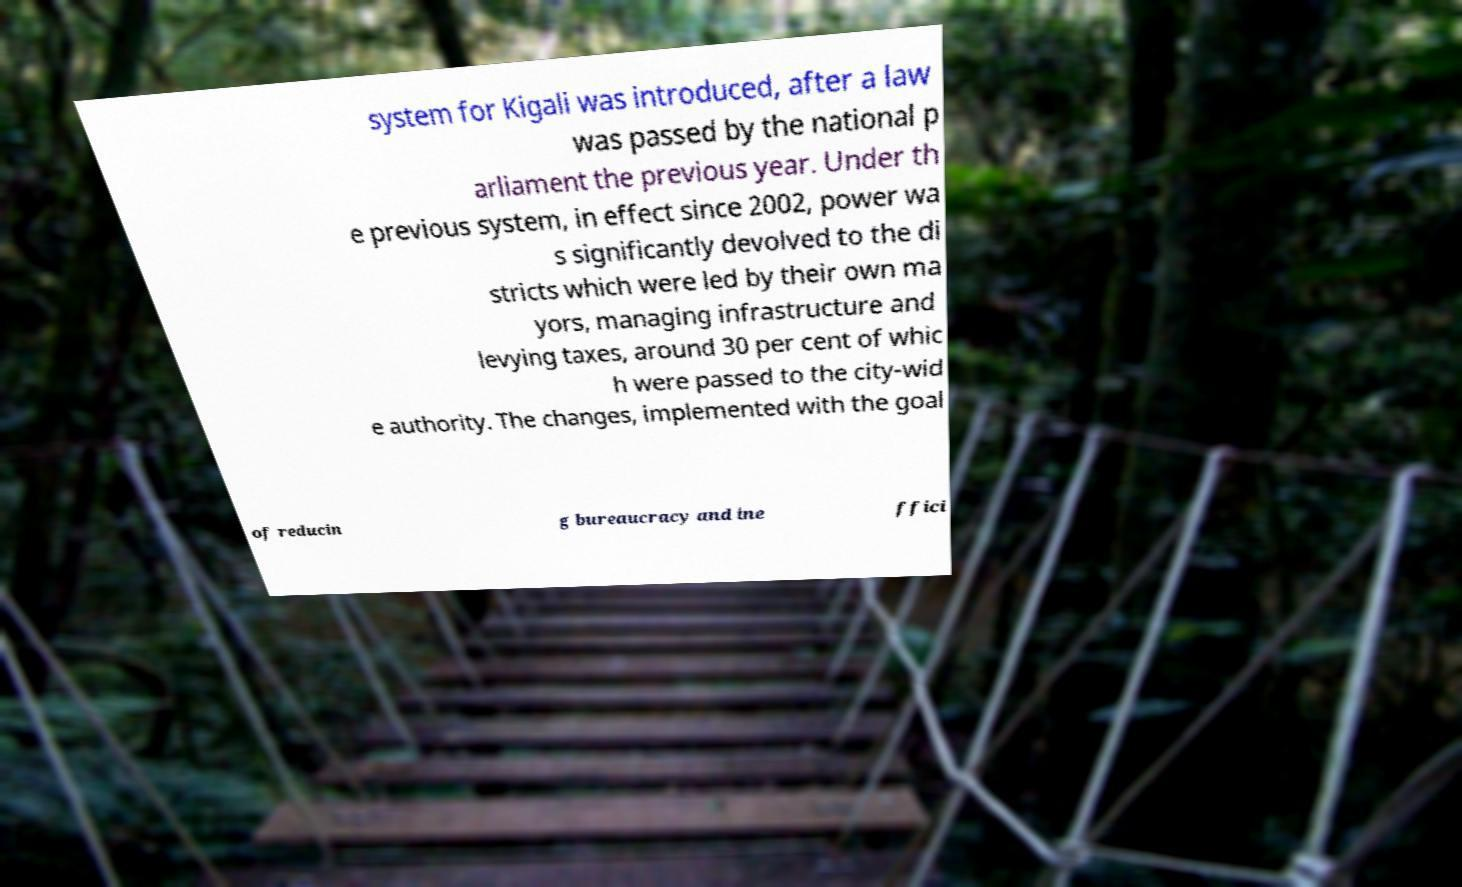Could you assist in decoding the text presented in this image and type it out clearly? system for Kigali was introduced, after a law was passed by the national p arliament the previous year. Under th e previous system, in effect since 2002, power wa s significantly devolved to the di stricts which were led by their own ma yors, managing infrastructure and levying taxes, around 30 per cent of whic h were passed to the city-wid e authority. The changes, implemented with the goal of reducin g bureaucracy and ine ffici 